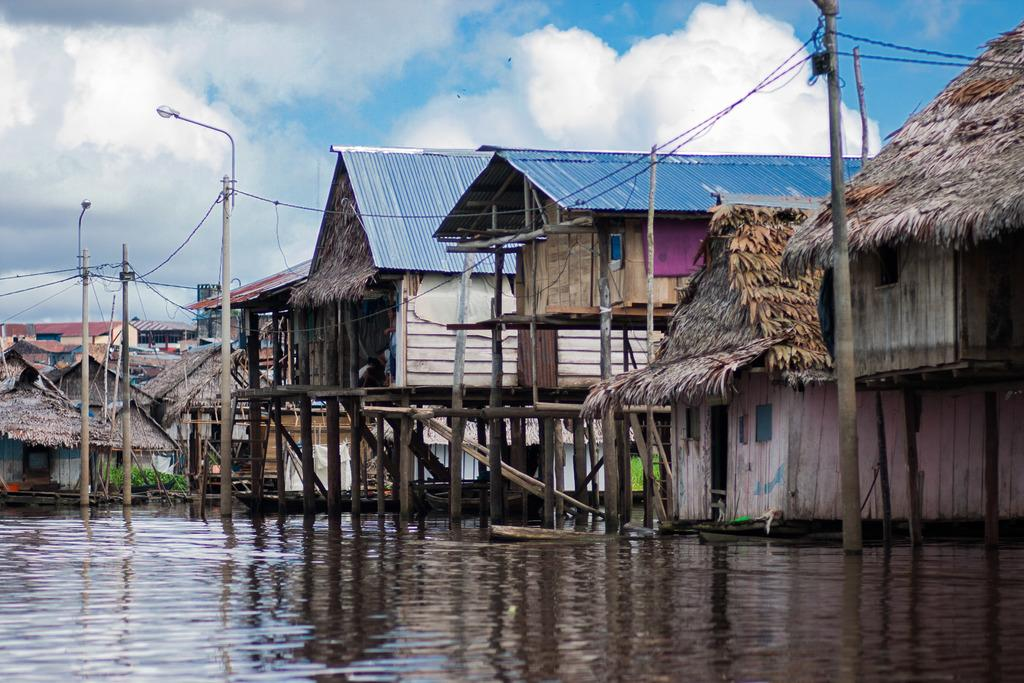What type of structures can be seen in the image? There are houses in the image. What else can be seen in the image besides the houses? There are poles with cables in the image. What natural element is visible in the image? There is water visible in the image. What is visible in the background of the image? The sky is visible in the image. What type of plants can be seen growing inside the houses in the image? There is no mention of plants growing inside the houses in the image; only houses, poles with cables, water, and the sky are visible. 